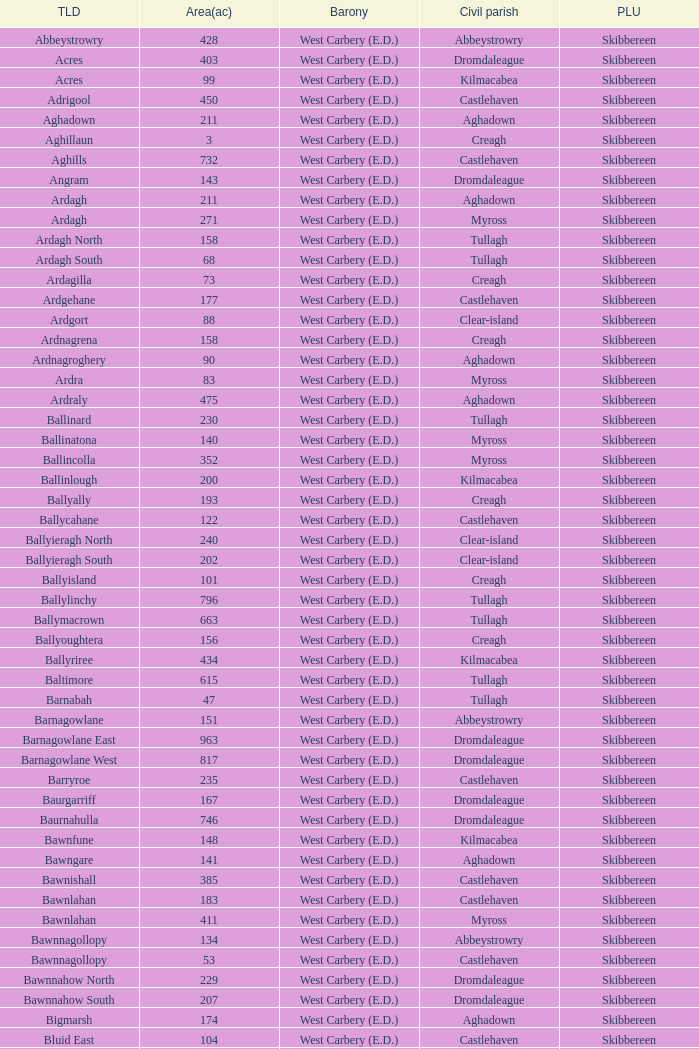What are the civil parishes of the Loughmarsh townland? Aghadown. 